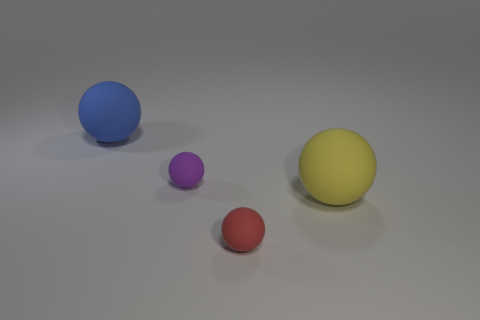Subtract all tiny purple matte balls. How many balls are left? 3 Subtract all red spheres. How many spheres are left? 3 Add 3 blue metal blocks. How many objects exist? 7 Subtract 2 balls. How many balls are left? 2 Add 4 small spheres. How many small spheres exist? 6 Subtract 1 blue balls. How many objects are left? 3 Subtract all cyan balls. Subtract all yellow blocks. How many balls are left? 4 Subtract all big yellow rubber blocks. Subtract all spheres. How many objects are left? 0 Add 3 blue objects. How many blue objects are left? 4 